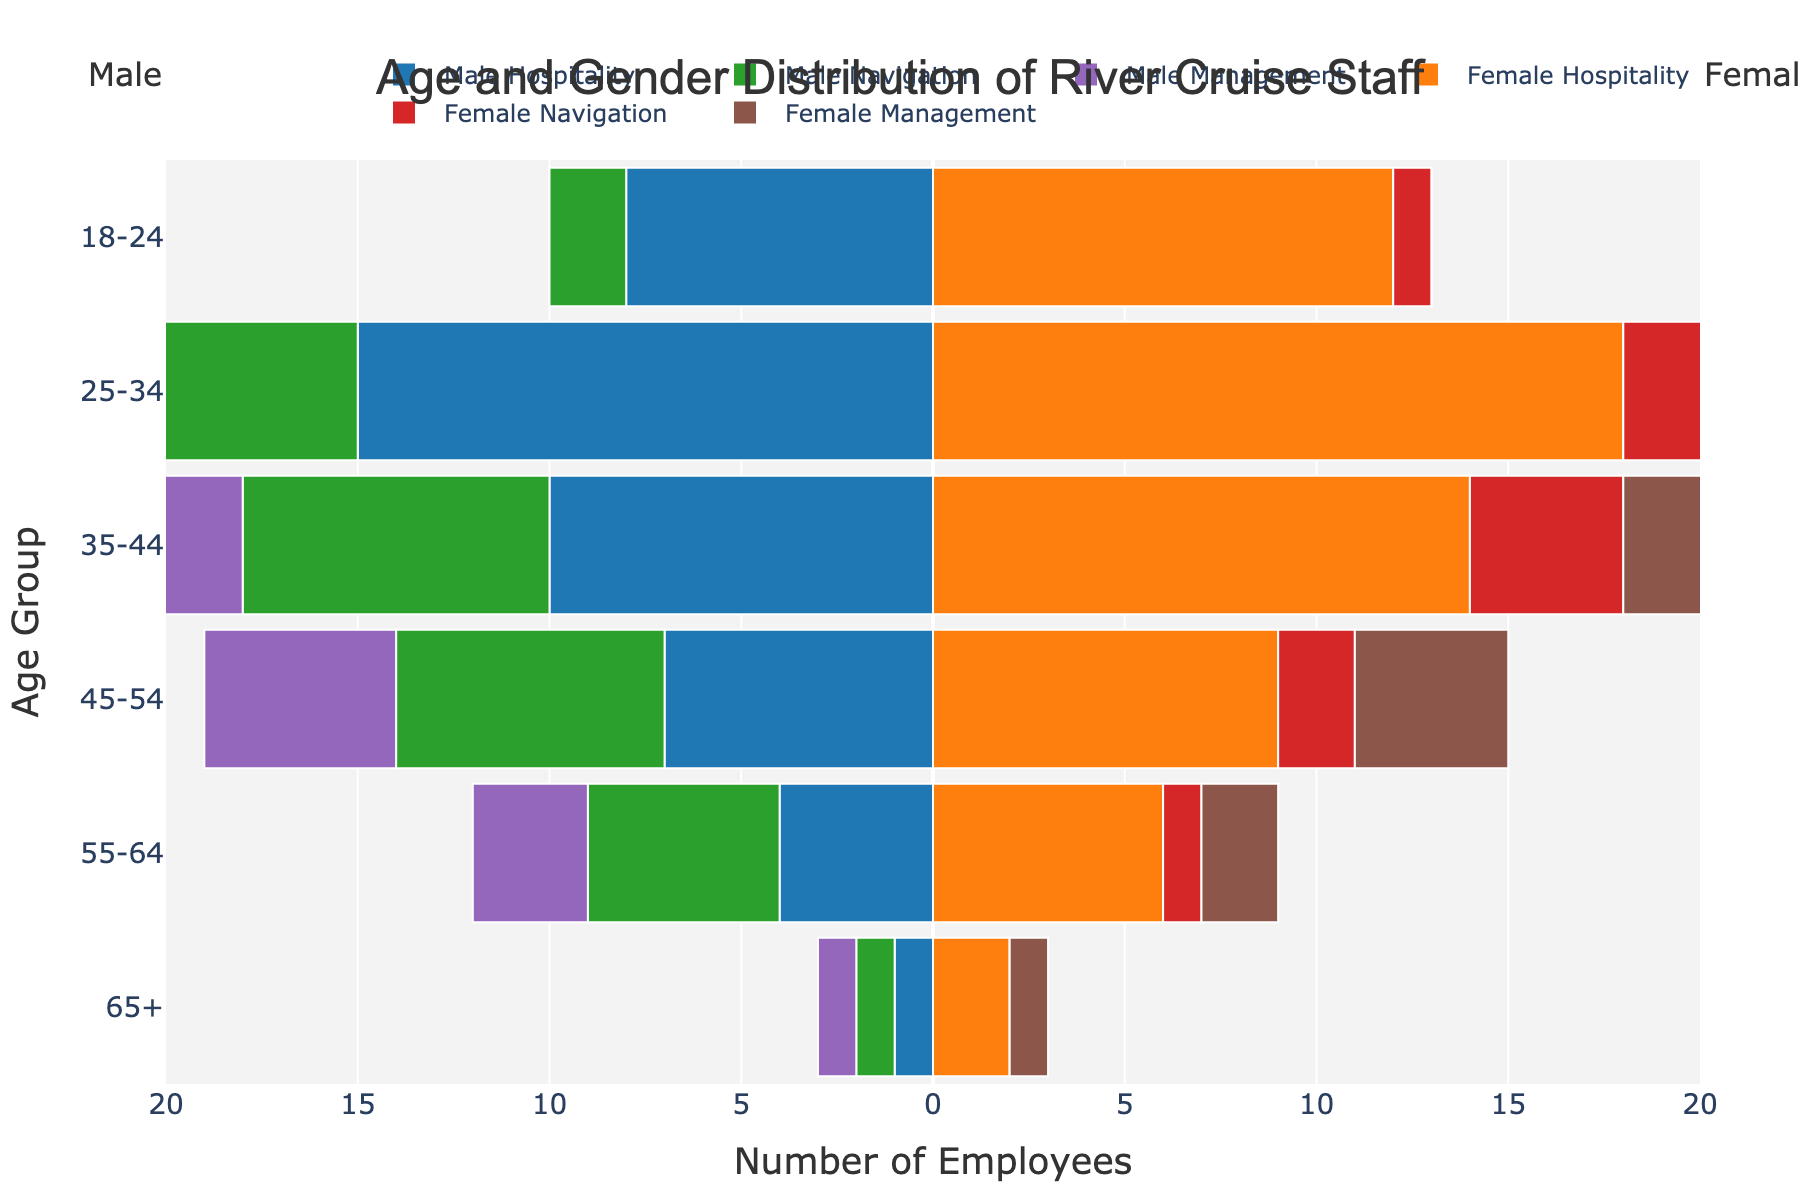What is the age group with the highest number of Male Hospitality staff? The Male Hospitality bar that extends the furthest to the left represents the highest number. The bar in the age group 25-34 extends the farthest.
Answer: 25-34 How many female staff are there in the 55-64 age group in total? Add the number of female staff across all roles in the 55-64 age group. Female Hospitality (6) + Female Navigation (1) + Female Management (2) = 9
Answer: 9 Which gender has more staff in the 35-44 age group for the Navigation role? Compare the length of the Male and Female Navigation bars in the 35-44 age group. The Male Navigation bar is longer (8 vs. 4).
Answer: Male What is the total number of Management staff in the age group 45-54? Add both Male and Female Management staff in the 45-54 age group. Male Management (5) + Female Management (4) = 9
Answer: 9 Which role has the least number of male staff in the age group 65+? Compare the lengths of the bars for Male roles in the 65+ age group. Navigation, Hospitality, and Management all have a length of 1, the least.
Answer: Navigation, Hospitality, and Management What is the difference in the number of Female Hospitality staff between ages 25-34 and 35-44? Subtract the number of Female Hospitality staff in the 35-44 age group from the number in the 25-34 group. 18 (25-34) - 14 (35-44) = 4
Answer: 4 In which age group is the total number of staff the highest? Evaluate the sum of all roles (Male + Female) in each age group. The 25-34 age group has the highest sum.
Answer: 25-34 What is the ratio of Female to Male Management staff in the 35-44 age group? Divide the number of Female Management staff by the number of Male Management staff in that age group. Female Management (3) / Male Management (4) = 0.75
Answer: 0.75 How many navigation staff are there in the age group 18-24? Add both Male and Female Navigation staff in the 18-24 age group. Male Navigation (2) + Female Navigation (1) = 3
Answer: 3 